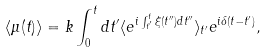Convert formula to latex. <formula><loc_0><loc_0><loc_500><loc_500>\langle \mu ( t ) \rangle = k \int _ { 0 } ^ { t } d t ^ { \prime } \langle e ^ { i \int _ { t ^ { \prime } } ^ { t } \xi ( t ^ { \prime \prime } ) d t ^ { \prime \prime } } \rangle _ { t ^ { \prime } } e ^ { i \delta ( t - t ^ { \prime } ) } ,</formula> 